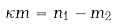<formula> <loc_0><loc_0><loc_500><loc_500>\kappa m = n _ { 1 } - m _ { 2 }</formula> 